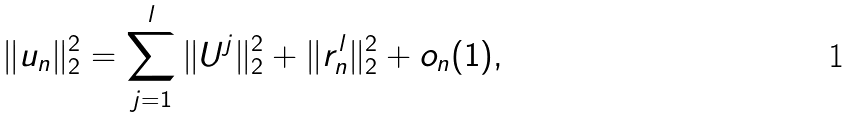<formula> <loc_0><loc_0><loc_500><loc_500>\| u _ { n } \| _ { 2 } ^ { 2 } = \sum _ { j = 1 } ^ { l } \| U ^ { j } \| _ { 2 } ^ { 2 } + \| r _ { n } ^ { l } \| _ { 2 } ^ { 2 } + o _ { n } ( 1 ) ,</formula> 